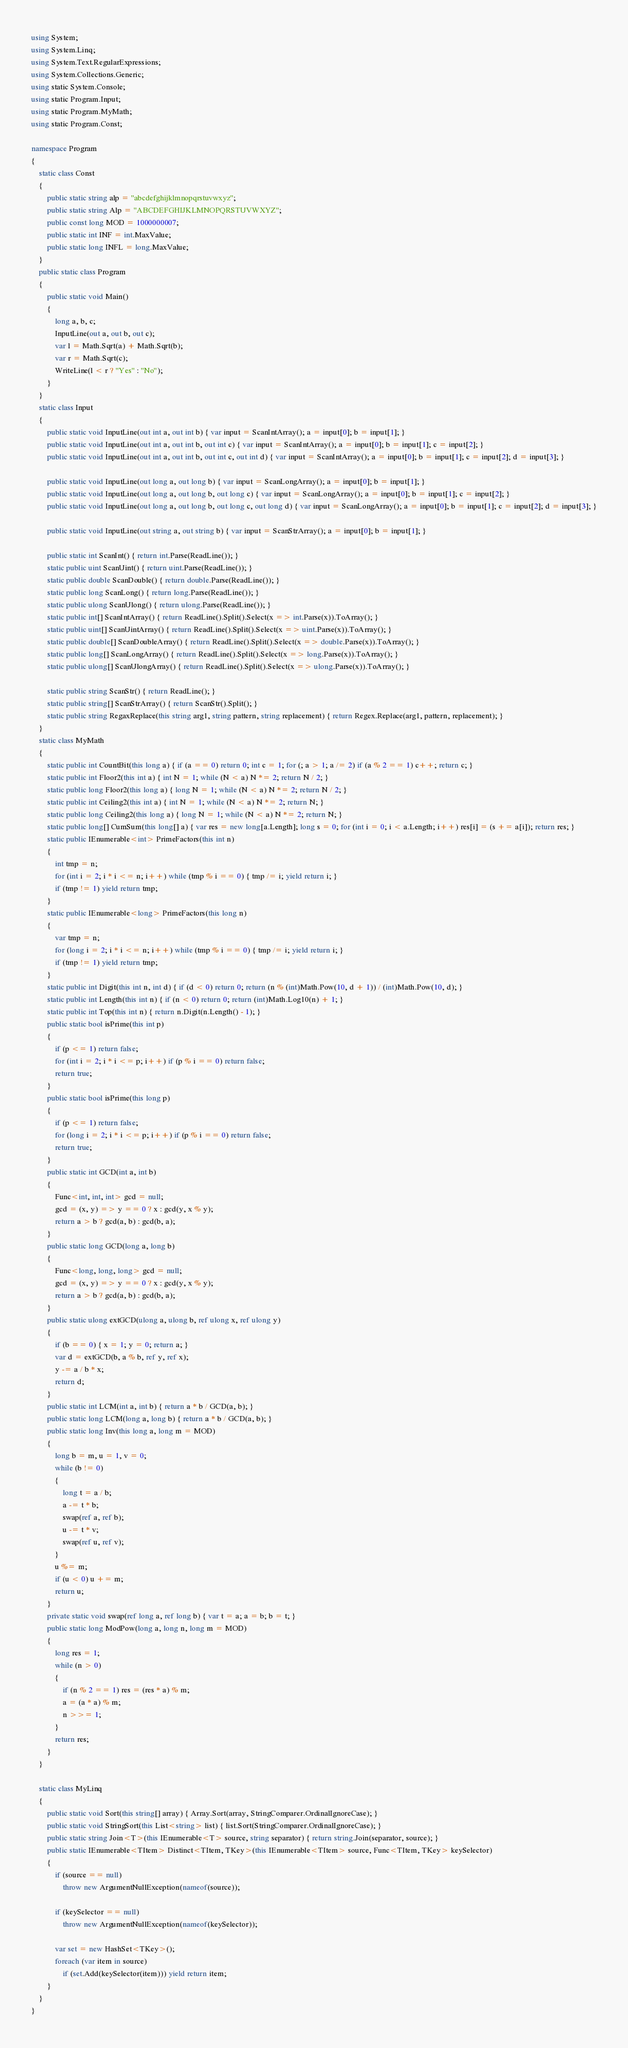<code> <loc_0><loc_0><loc_500><loc_500><_C#_>using System;
using System.Linq;
using System.Text.RegularExpressions;
using System.Collections.Generic;
using static System.Console;
using static Program.Input;
using static Program.MyMath;
using static Program.Const;

namespace Program
{
    static class Const
    {
        public static string alp = "abcdefghijklmnopqrstuvwxyz";
        public static string Alp = "ABCDEFGHIJKLMNOPQRSTUVWXYZ";
        public const long MOD = 1000000007;
        public static int INF = int.MaxValue;
        public static long INFL = long.MaxValue;
    }
    public static class Program
    {
        public static void Main()
        {
            long a, b, c;
            InputLine(out a, out b, out c);
            var l = Math.Sqrt(a) + Math.Sqrt(b);
            var r = Math.Sqrt(c);
            WriteLine(l < r ? "Yes" : "No");
        }
    }
    static class Input
    {
        public static void InputLine(out int a, out int b) { var input = ScanIntArray(); a = input[0]; b = input[1]; }
        public static void InputLine(out int a, out int b, out int c) { var input = ScanIntArray(); a = input[0]; b = input[1]; c = input[2]; }
        public static void InputLine(out int a, out int b, out int c, out int d) { var input = ScanIntArray(); a = input[0]; b = input[1]; c = input[2]; d = input[3]; }

        public static void InputLine(out long a, out long b) { var input = ScanLongArray(); a = input[0]; b = input[1]; }
        public static void InputLine(out long a, out long b, out long c) { var input = ScanLongArray(); a = input[0]; b = input[1]; c = input[2]; }
        public static void InputLine(out long a, out long b, out long c, out long d) { var input = ScanLongArray(); a = input[0]; b = input[1]; c = input[2]; d = input[3]; }

        public static void InputLine(out string a, out string b) { var input = ScanStrArray(); a = input[0]; b = input[1]; }

        public static int ScanInt() { return int.Parse(ReadLine()); }
        static public uint ScanUint() { return uint.Parse(ReadLine()); }
        static public double ScanDouble() { return double.Parse(ReadLine()); }
        static public long ScanLong() { return long.Parse(ReadLine()); }
        static public ulong ScanUlong() { return ulong.Parse(ReadLine()); }
        static public int[] ScanIntArray() { return ReadLine().Split().Select(x => int.Parse(x)).ToArray(); }
        static public uint[] ScanUintArray() { return ReadLine().Split().Select(x => uint.Parse(x)).ToArray(); }
        static public double[] ScanDoubleArray() { return ReadLine().Split().Select(x => double.Parse(x)).ToArray(); }
        static public long[] ScanLongArray() { return ReadLine().Split().Select(x => long.Parse(x)).ToArray(); }
        static public ulong[] ScanUlongArray() { return ReadLine().Split().Select(x => ulong.Parse(x)).ToArray(); }

        static public string ScanStr() { return ReadLine(); }
        static public string[] ScanStrArray() { return ScanStr().Split(); }
        static public string RegaxReplace(this string arg1, string pattern, string replacement) { return Regex.Replace(arg1, pattern, replacement); }
    }
    static class MyMath
    {
        static public int CountBit(this long a) { if (a == 0) return 0; int c = 1; for (; a > 1; a /= 2) if (a % 2 == 1) c++; return c; }
        static public int Floor2(this int a) { int N = 1; while (N < a) N *= 2; return N / 2; }
        static public long Floor2(this long a) { long N = 1; while (N < a) N *= 2; return N / 2; }
        static public int Ceiling2(this int a) { int N = 1; while (N < a) N *= 2; return N; }
        static public long Ceiling2(this long a) { long N = 1; while (N < a) N *= 2; return N; }
        static public long[] CumSum(this long[] a) { var res = new long[a.Length]; long s = 0; for (int i = 0; i < a.Length; i++) res[i] = (s += a[i]); return res; }
        static public IEnumerable<int> PrimeFactors(this int n)
        {
            int tmp = n;
            for (int i = 2; i * i <= n; i++) while (tmp % i == 0) { tmp /= i; yield return i; }
            if (tmp != 1) yield return tmp;
        }
        static public IEnumerable<long> PrimeFactors(this long n)
        {
            var tmp = n;
            for (long i = 2; i * i <= n; i++) while (tmp % i == 0) { tmp /= i; yield return i; }
            if (tmp != 1) yield return tmp;
        }
        static public int Digit(this int n, int d) { if (d < 0) return 0; return (n % (int)Math.Pow(10, d + 1)) / (int)Math.Pow(10, d); }
        static public int Length(this int n) { if (n < 0) return 0; return (int)Math.Log10(n) + 1; }
        static public int Top(this int n) { return n.Digit(n.Length() - 1); }
        public static bool isPrime(this int p)
        {
            if (p <= 1) return false;
            for (int i = 2; i * i <= p; i++) if (p % i == 0) return false;
            return true;
        }
        public static bool isPrime(this long p)
        {
            if (p <= 1) return false;
            for (long i = 2; i * i <= p; i++) if (p % i == 0) return false;
            return true;
        }
        public static int GCD(int a, int b)
        {
            Func<int, int, int> gcd = null;
            gcd = (x, y) => y == 0 ? x : gcd(y, x % y);
            return a > b ? gcd(a, b) : gcd(b, a);
        }
        public static long GCD(long a, long b)
        {
            Func<long, long, long> gcd = null;
            gcd = (x, y) => y == 0 ? x : gcd(y, x % y);
            return a > b ? gcd(a, b) : gcd(b, a);
        }
        public static ulong extGCD(ulong a, ulong b, ref ulong x, ref ulong y)
        {
            if (b == 0) { x = 1; y = 0; return a; }
            var d = extGCD(b, a % b, ref y, ref x);
            y -= a / b * x;
            return d;
        }
        public static int LCM(int a, int b) { return a * b / GCD(a, b); }
        public static long LCM(long a, long b) { return a * b / GCD(a, b); }
        public static long Inv(this long a, long m = MOD)
        {
            long b = m, u = 1, v = 0;
            while (b != 0)
            {
                long t = a / b;
                a -= t * b;
                swap(ref a, ref b);
                u -= t * v;
                swap(ref u, ref v);
            }
            u %= m;
            if (u < 0) u += m;
            return u;
        }
        private static void swap(ref long a, ref long b) { var t = a; a = b; b = t; }
        public static long ModPow(long a, long n, long m = MOD)
        {
            long res = 1;
            while (n > 0)
            {
                if (n % 2 == 1) res = (res * a) % m;
                a = (a * a) % m;
                n >>= 1;
            }
            return res;
        }
    }

    static class MyLinq
    {
        public static void Sort(this string[] array) { Array.Sort(array, StringComparer.OrdinalIgnoreCase); }
        public static void StringSort(this List<string> list) { list.Sort(StringComparer.OrdinalIgnoreCase); }
        public static string Join<T>(this IEnumerable<T> source, string separator) { return string.Join(separator, source); }
        public static IEnumerable<TItem> Distinct<TItem, TKey>(this IEnumerable<TItem> source, Func<TItem, TKey> keySelector)
        {
            if (source == null)
                throw new ArgumentNullException(nameof(source));

            if (keySelector == null)
                throw new ArgumentNullException(nameof(keySelector));

            var set = new HashSet<TKey>();
            foreach (var item in source)
                if (set.Add(keySelector(item))) yield return item;
        }
    }
}
</code> 